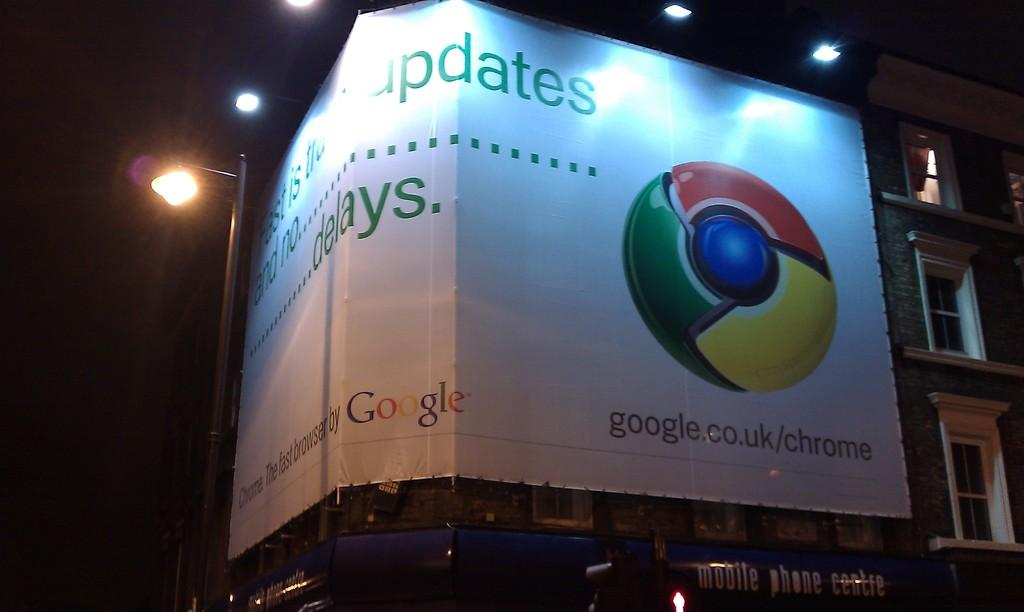What is displayed on the banner in the image? There is a banner with text and a logo in the image. Where is the banner located? The banner is placed on a building. What can be seen in the background of the image? There are lights and a pole visible in the background of the image. What is present at the bottom of the image? There are boards at the bottom of the image. What is the head of the person doing in the image? There is no person present in the image, so there is no head of a person to discuss. 